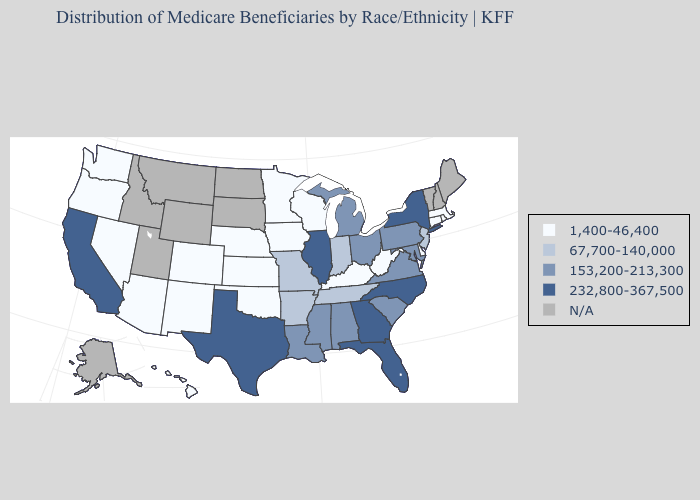Which states hav the highest value in the MidWest?
Concise answer only. Illinois. Name the states that have a value in the range 232,800-367,500?
Short answer required. California, Florida, Georgia, Illinois, New York, North Carolina, Texas. Which states have the lowest value in the USA?
Short answer required. Arizona, Colorado, Connecticut, Delaware, Hawaii, Iowa, Kansas, Kentucky, Massachusetts, Minnesota, Nebraska, Nevada, New Mexico, Oklahoma, Oregon, Rhode Island, Washington, West Virginia, Wisconsin. Name the states that have a value in the range 232,800-367,500?
Give a very brief answer. California, Florida, Georgia, Illinois, New York, North Carolina, Texas. Does Virginia have the highest value in the USA?
Short answer required. No. What is the value of North Carolina?
Be succinct. 232,800-367,500. Among the states that border Tennessee , does Kentucky have the lowest value?
Be succinct. Yes. Among the states that border Michigan , which have the lowest value?
Short answer required. Wisconsin. What is the value of Michigan?
Give a very brief answer. 153,200-213,300. Name the states that have a value in the range 153,200-213,300?
Concise answer only. Alabama, Louisiana, Maryland, Michigan, Mississippi, Ohio, Pennsylvania, South Carolina, Virginia. What is the value of Arizona?
Write a very short answer. 1,400-46,400. Name the states that have a value in the range 232,800-367,500?
Write a very short answer. California, Florida, Georgia, Illinois, New York, North Carolina, Texas. Which states have the highest value in the USA?
Answer briefly. California, Florida, Georgia, Illinois, New York, North Carolina, Texas. Does California have the highest value in the USA?
Quick response, please. Yes. What is the value of Louisiana?
Answer briefly. 153,200-213,300. 